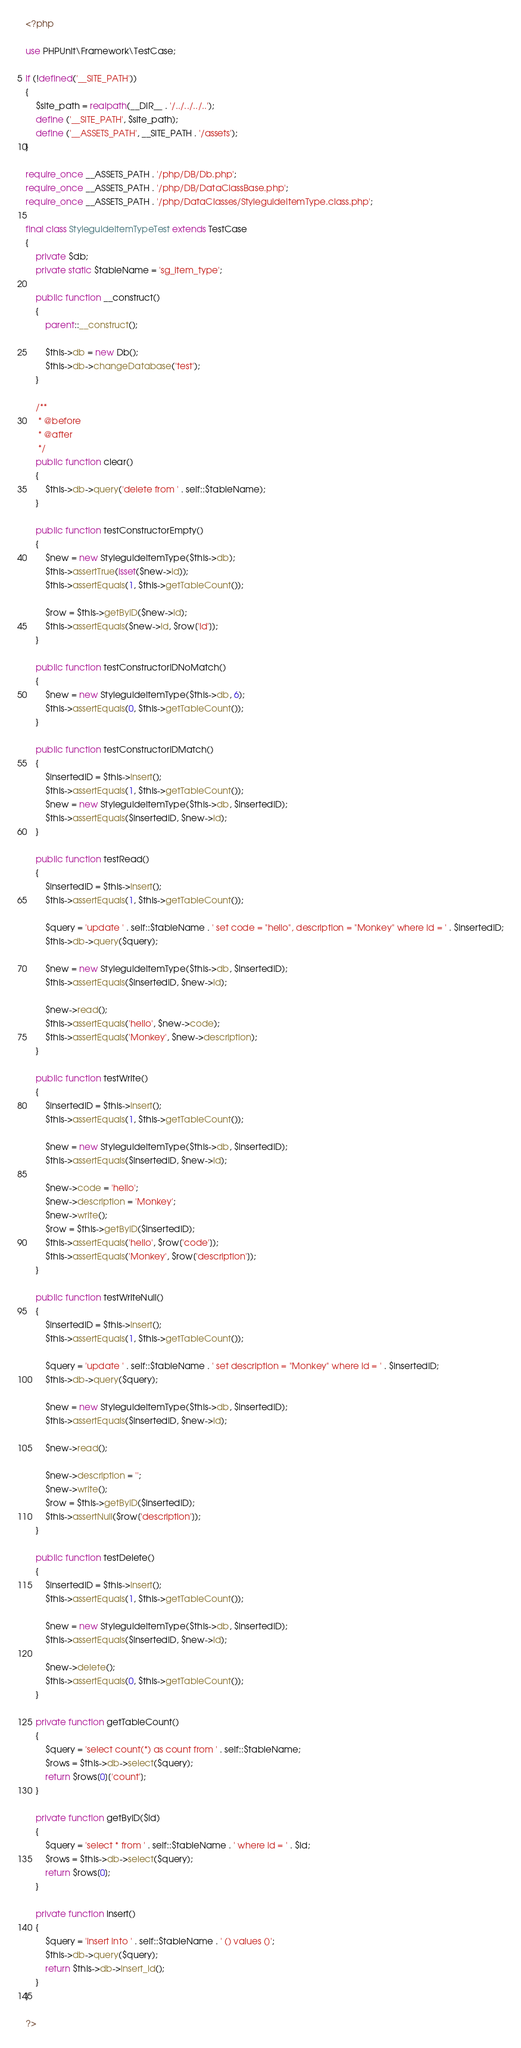<code> <loc_0><loc_0><loc_500><loc_500><_PHP_><?php

use PHPUnit\Framework\TestCase;

if (!defined('__SITE_PATH'))
{
	$site_path = realpath(__DIR__ . '/../../../..');
	define ('__SITE_PATH', $site_path);
	define ('__ASSETS_PATH', __SITE_PATH . '/assets');
}

require_once __ASSETS_PATH . '/php/DB/Db.php';
require_once __ASSETS_PATH . '/php/DB/DataClassBase.php';
require_once __ASSETS_PATH . '/php/DataClasses/StyleguideItemType.class.php';

final class StyleguideItemTypeTest extends TestCase
{
	private $db;
	private static $tableName = 'sg_item_type';
	
	public function __construct()
	{
		parent::__construct();
		
		$this->db = new Db();
		$this->db->changeDatabase('test');
	}
	
	/**
     * @before
	 * @after
     */
	public function clear()
	{
		$this->db->query('delete from ' . self::$tableName);
	}
	
    public function testConstructorEmpty()
    {
		$new = new StyleguideItemType($this->db);
		$this->assertTrue(isset($new->id));
		$this->assertEquals(1, $this->getTableCount());
		
		$row = $this->getByID($new->id);
		$this->assertEquals($new->id, $row['id']);
	}
	
	public function testConstructorIDNoMatch()
    {
		$new = new StyleguideItemType($this->db, 6);
		$this->assertEquals(0, $this->getTableCount());
	}
	
	public function testConstructorIDMatch()
    {
		$insertedID = $this->insert();
		$this->assertEquals(1, $this->getTableCount());
		$new = new StyleguideItemType($this->db, $insertedID);
		$this->assertEquals($insertedID, $new->id);
	}
	
	public function testRead()
    {
		$insertedID = $this->insert();
		$this->assertEquals(1, $this->getTableCount());
		
		$query = 'update ' . self::$tableName . ' set code = "hello", description = "Monkey" where id = ' . $insertedID;
		$this->db->query($query);
		
		$new = new StyleguideItemType($this->db, $insertedID);
		$this->assertEquals($insertedID, $new->id);
		
		$new->read();
		$this->assertEquals('hello', $new->code);
		$this->assertEquals('Monkey', $new->description);
	}
	
	public function testWrite()
    {
		$insertedID = $this->insert();
		$this->assertEquals(1, $this->getTableCount());
		
		$new = new StyleguideItemType($this->db, $insertedID);
		$this->assertEquals($insertedID, $new->id);
		
		$new->code = 'hello';
		$new->description = 'Monkey';
		$new->write();
		$row = $this->getByID($insertedID);
		$this->assertEquals('hello', $row['code']);
		$this->assertEquals('Monkey', $row['description']);
	}
	
	public function testWriteNull()
	{
		$insertedID = $this->insert();
		$this->assertEquals(1, $this->getTableCount());
		
		$query = 'update ' . self::$tableName . ' set description = "Monkey" where id = ' . $insertedID;
		$this->db->query($query);
		
		$new = new StyleguideItemType($this->db, $insertedID);
		$this->assertEquals($insertedID, $new->id);
		
		$new->read();
		
		$new->description = '';
		$new->write();
		$row = $this->getByID($insertedID);
		$this->assertNull($row['description']);
	}
	
	public function testDelete()
    {
		$insertedID = $this->insert();
		$this->assertEquals(1, $this->getTableCount());
		
		$new = new StyleguideItemType($this->db, $insertedID);
		$this->assertEquals($insertedID, $new->id);
		
		$new->delete();
		$this->assertEquals(0, $this->getTableCount());
	}
	
	private function getTableCount()
	{
		$query = 'select count(*) as count from ' . self::$tableName;
		$rows = $this->db->select($query);
		return $rows[0]['count'];
	}
	
	private function getByID($id)
	{
		$query = 'select * from ' . self::$tableName . ' where id = ' . $id;
		$rows = $this->db->select($query);
		return $rows[0];
	}
	
	private function insert()
	{
		$query = 'insert into ' . self::$tableName . ' () values ()';
		$this->db->query($query);
		return $this->db->insert_id();
	}
}

?></code> 